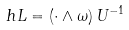<formula> <loc_0><loc_0><loc_500><loc_500>\ h L = ( \cdot \wedge \omega ) \, U ^ { - 1 }</formula> 